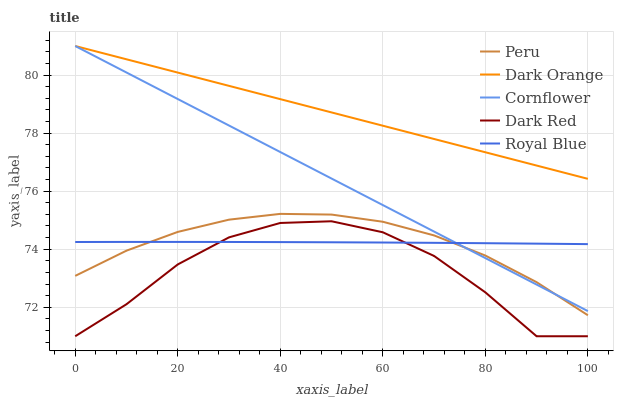Does Dark Orange have the minimum area under the curve?
Answer yes or no. No. Does Dark Red have the maximum area under the curve?
Answer yes or no. No. Is Dark Orange the smoothest?
Answer yes or no. No. Is Dark Orange the roughest?
Answer yes or no. No. Does Dark Orange have the lowest value?
Answer yes or no. No. Does Dark Red have the highest value?
Answer yes or no. No. Is Royal Blue less than Dark Orange?
Answer yes or no. Yes. Is Dark Orange greater than Peru?
Answer yes or no. Yes. Does Royal Blue intersect Dark Orange?
Answer yes or no. No. 